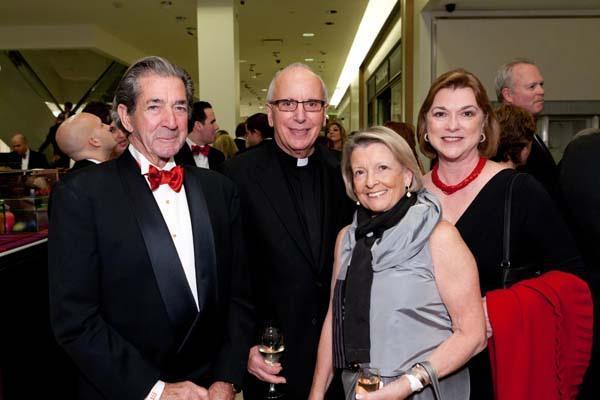How many ties are there?
Give a very brief answer. 1. How many people are in the picture?
Give a very brief answer. 9. 